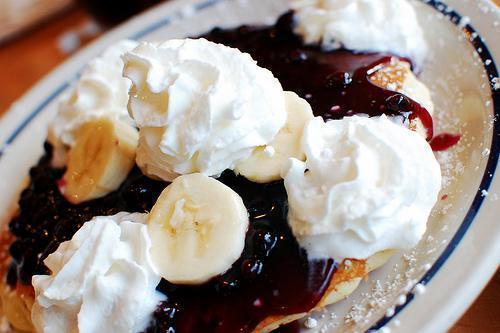How many banana slices are there?
Give a very brief answer. 3. How many globs of cool whip?
Give a very brief answer. 5. 